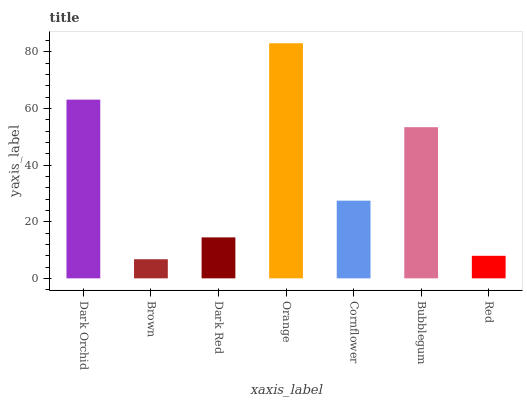Is Dark Red the minimum?
Answer yes or no. No. Is Dark Red the maximum?
Answer yes or no. No. Is Dark Red greater than Brown?
Answer yes or no. Yes. Is Brown less than Dark Red?
Answer yes or no. Yes. Is Brown greater than Dark Red?
Answer yes or no. No. Is Dark Red less than Brown?
Answer yes or no. No. Is Cornflower the high median?
Answer yes or no. Yes. Is Cornflower the low median?
Answer yes or no. Yes. Is Brown the high median?
Answer yes or no. No. Is Brown the low median?
Answer yes or no. No. 